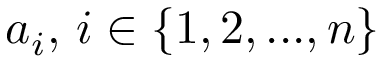<formula> <loc_0><loc_0><loc_500><loc_500>a _ { i } , \, i \in \{ 1 , 2 , \dots , n \}</formula> 